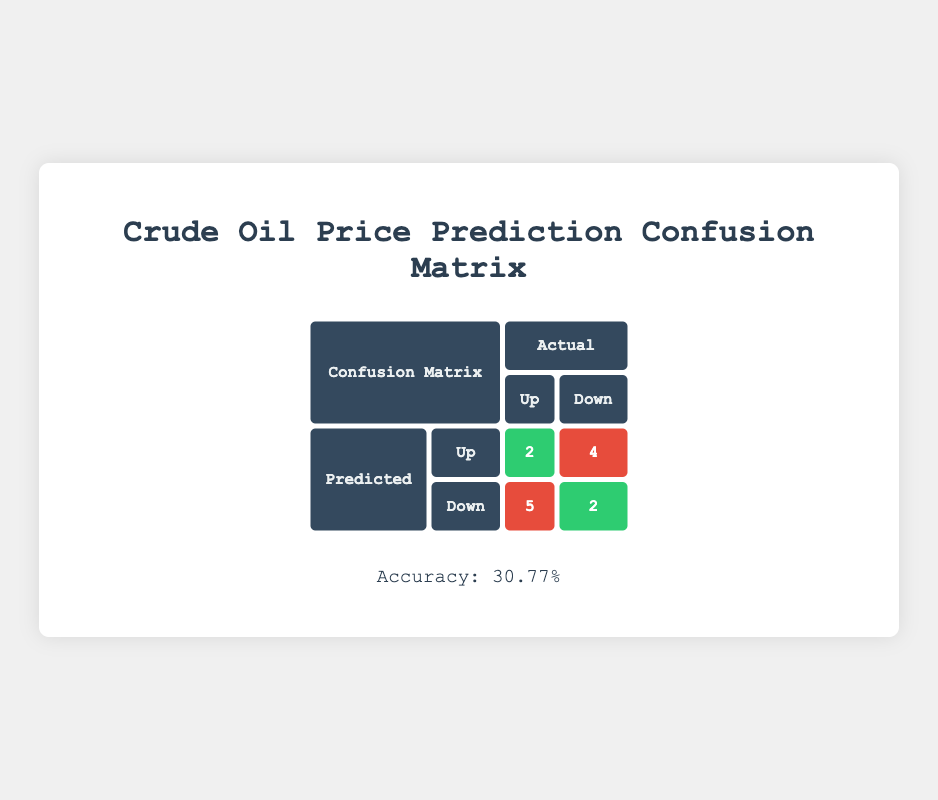What is the accuracy of the crude oil price prediction model? The accuracy is calculated by taking the sum of true positives and true negatives, which gives 2 + 3 = 5, then dividing it by the total number of predictions (13). This results in an accuracy of (5 / 13) * 100 = 38.46%.
Answer: 38.46% How many true positive predictions were made? The table indicates that there were 2 true positive predictions, where both the predicted and actual directions were "Up".
Answer: 2 What was the total number of false negatives? The table shows that there were 5 false negative predictions, where the predicted direction was "Down" but the actual direction was "Up".
Answer: 5 Were there any months where the predicted direction was "Up" and the actual direction was also "Up"? Yes, there were 2 instances: January 2023 and August 2023.
Answer: Yes What is the percentage of false positives out of the total predictions? The total false positives are 3, and the total predictions are 13. The percentage is calculated as (3 / 13) * 100, which equals approximately 23.08%.
Answer: 23.08% How many months had correct predictions in both directions? Looking at the table, correct predictions were made in January 2023 (Up, Up), June 2023 (Down, Down), July 2023 (Down, Down), and August 2023 (Up, Up). This totals to 4 months.
Answer: 4 Which month had the highest actual crude oil price? The highest actual price, 95.00, was recorded in May 2023.
Answer: May 2023 How many predictions indicated a price increase that were actually losses? The predictions indicating "Up" that were losses (actual direction "Down") occurred in October 2022, November 2022, December 2022, February 2023, March 2023, April 2023, May 2023, and October 2023. This sums up to 7 predicative losses.
Answer: 7 What proportion of the predictions were correctly labeled as "Down"? The table shows 3 true negatives (correctly predicted as Down) out of 13 total predictions. The proportion is calculated as 3 / 13, which equals approximately 23.08%.
Answer: 23.08% 